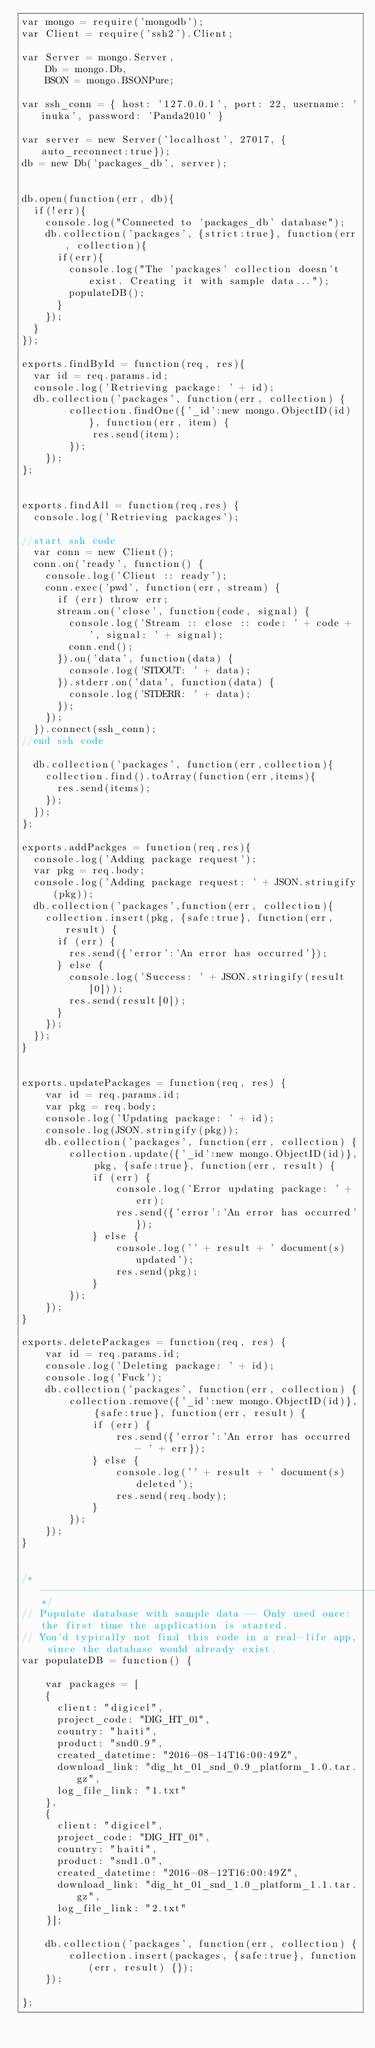<code> <loc_0><loc_0><loc_500><loc_500><_JavaScript_>var mongo = require('mongodb');
var Client = require('ssh2').Client;

var Server = mongo.Server,
    Db = mongo.Db,
    BSON = mongo.BSONPure;

var ssh_conn = { host: '127.0.0.1', port: 22, username: 'inuka', password: 'Panda2010' }

var server = new Server('localhost', 27017, {auto_reconnect:true});
db = new Db('packages_db', server);


db.open(function(err, db){
  if(!err){
    console.log("Connected to 'packages_db' database");
    db.collection('packages', {strict:true}, function(err, collection){
      if(err){
        console.log("The 'packages' collection doesn't exist. Creating it with sample data...");
        populateDB();
      }
    });
  }
});

exports.findById = function(req, res){
  var id = req.params.id;
  console.log('Retrieving package: ' + id);
  db.collection('packages', function(err, collection) {
        collection.findOne({'_id':new mongo.ObjectID(id)}, function(err, item) {
            res.send(item);
        });
    });
};


exports.findAll = function(req,res) {
  console.log('Retrieving packages');

//start ssh code
  var conn = new Client();
  conn.on('ready', function() {
    console.log('Client :: ready');
    conn.exec('pwd', function(err, stream) {
      if (err) throw err;
      stream.on('close', function(code, signal) {
        console.log('Stream :: close :: code: ' + code + ', signal: ' + signal);
        conn.end();
      }).on('data', function(data) {
        console.log('STDOUT: ' + data);
      }).stderr.on('data', function(data) {
        console.log('STDERR: ' + data);
      });
    });
  }).connect(ssh_conn);
//end ssh code

  db.collection('packages', function(err,collection){
    collection.find().toArray(function(err,items){
      res.send(items);
    });
  });
};

exports.addPackges = function(req,res){
  console.log('Adding package request');
  var pkg = req.body;
  console.log('Adding package request: ' + JSON.stringify(pkg));
  db.collection('packages',function(err, collection){
    collection.insert(pkg, {safe:true}, function(err, result) {
      if (err) {
        res.send({'error':'An error has occurred'});
      } else {
        console.log('Success: ' + JSON.stringify(result[0]));
        res.send(result[0]);
      }
    });
  });
}


exports.updatePackages = function(req, res) {
    var id = req.params.id;
    var pkg = req.body;
    console.log('Updating package: ' + id);
    console.log(JSON.stringify(pkg));
    db.collection('packages', function(err, collection) {
        collection.update({'_id':new mongo.ObjectID(id)}, pkg, {safe:true}, function(err, result) {
            if (err) {
                console.log('Error updating package: ' + err);
                res.send({'error':'An error has occurred'});
            } else {
                console.log('' + result + ' document(s) updated');
                res.send(pkg);
            }
        });
    });
}

exports.deletePackages = function(req, res) {
    var id = req.params.id;
    console.log('Deleting package: ' + id);
    console.log('Fuck');
    db.collection('packages', function(err, collection) {
        collection.remove({'_id':new mongo.ObjectID(id)}, {safe:true}, function(err, result) {
            if (err) {
                res.send({'error':'An error has occurred - ' + err});
            } else {
                console.log('' + result + ' document(s) deleted');
                res.send(req.body);
            }
        });
    });
}


/*--------------------------------------------------------------------------------------------------------------------*/
// Populate database with sample data -- Only used once: the first time the application is started.
// You'd typically not find this code in a real-life app, since the database would already exist.
var populateDB = function() {

    var packages = [
    {
      client: "digicel",
      project_code: "DIG_HT_01",
      country: "haiti",
      product: "snd0.9",
      created_datetime: "2016-08-14T16:00:49Z",
      download_link: "dig_ht_01_snd_0.9_platform_1.0.tar.gz",
      log_file_link: "1.txt"
    },
    {
      client: "digicel",
      project_code: "DIG_HT_01",
      country: "haiti",
      product: "snd1.0",
      created_datetime: "2016-08-12T16:00:49Z",
      download_link: "dig_ht_01_snd_1.0_platform_1.1.tar.gz",
      log_file_link: "2.txt"
    }];

    db.collection('packages', function(err, collection) {
        collection.insert(packages, {safe:true}, function(err, result) {});
    });

};
</code> 